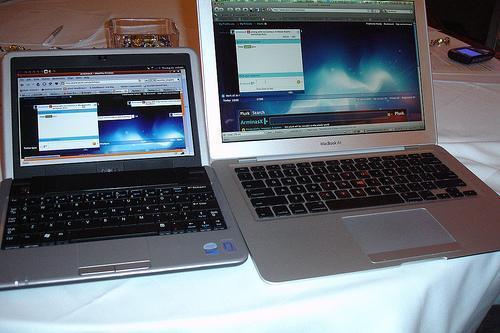How many laptops?
Give a very brief answer. 2. 